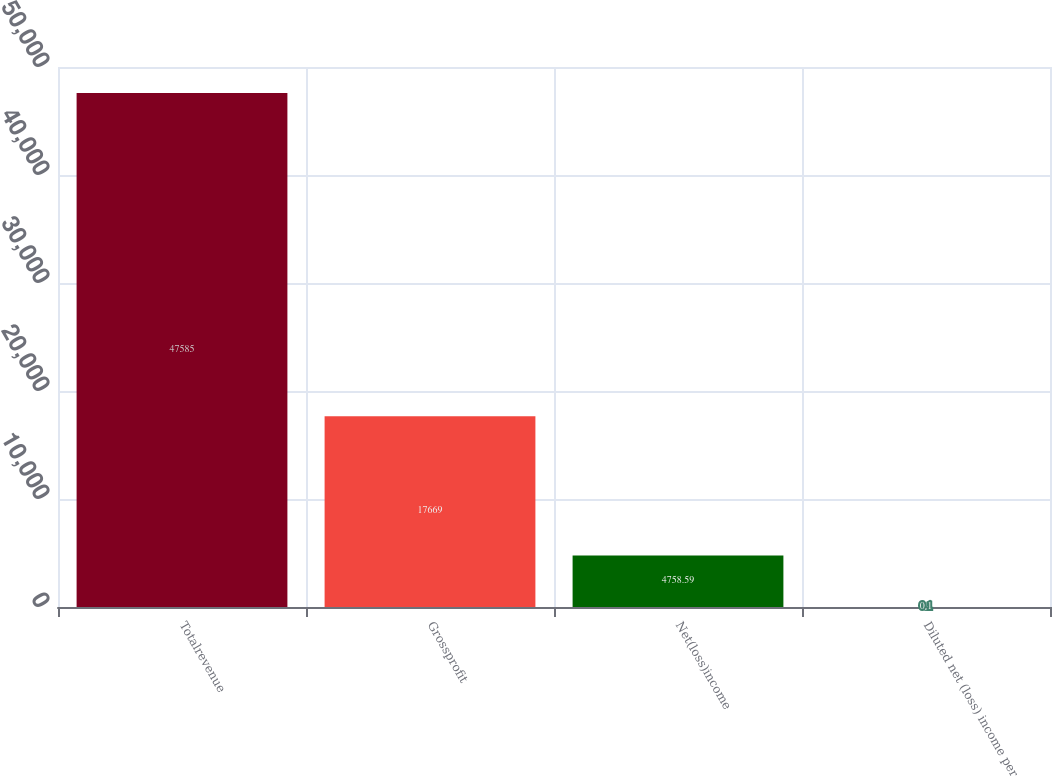<chart> <loc_0><loc_0><loc_500><loc_500><bar_chart><fcel>Totalrevenue<fcel>Grossprofit<fcel>Net(loss)income<fcel>Diluted net (loss) income per<nl><fcel>47585<fcel>17669<fcel>4758.59<fcel>0.1<nl></chart> 